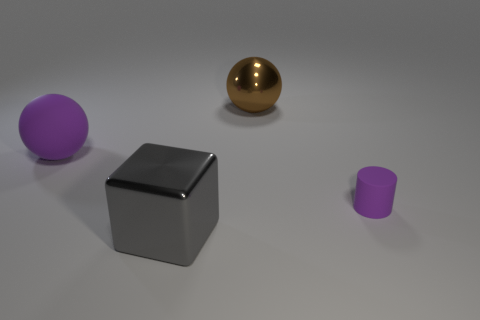The other rubber thing that is the same shape as the big brown thing is what color?
Ensure brevity in your answer.  Purple. Do the brown metallic ball and the gray cube have the same size?
Your response must be concise. Yes. What number of things are cyan matte cylinders or purple rubber things behind the tiny purple rubber thing?
Ensure brevity in your answer.  1. What is the color of the metal thing that is behind the purple matte cylinder that is on the right side of the large shiny block?
Your answer should be compact. Brown. There is a large metallic object that is behind the small purple object; is its color the same as the small matte thing?
Provide a short and direct response. No. There is a purple thing that is on the right side of the big gray object; what is its material?
Offer a very short reply. Rubber. How big is the rubber cylinder?
Offer a very short reply. Small. Do the tiny purple object right of the brown metal sphere and the gray cube have the same material?
Your answer should be compact. No. How many large brown spheres are there?
Offer a terse response. 1. What number of objects are gray things or purple matte objects?
Make the answer very short. 3. 